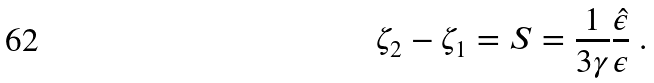Convert formula to latex. <formula><loc_0><loc_0><loc_500><loc_500>\zeta _ { 2 } - \zeta _ { 1 } = S = \frac { 1 } { 3 \gamma } \frac { \hat { \epsilon } } { \epsilon } \ .</formula> 